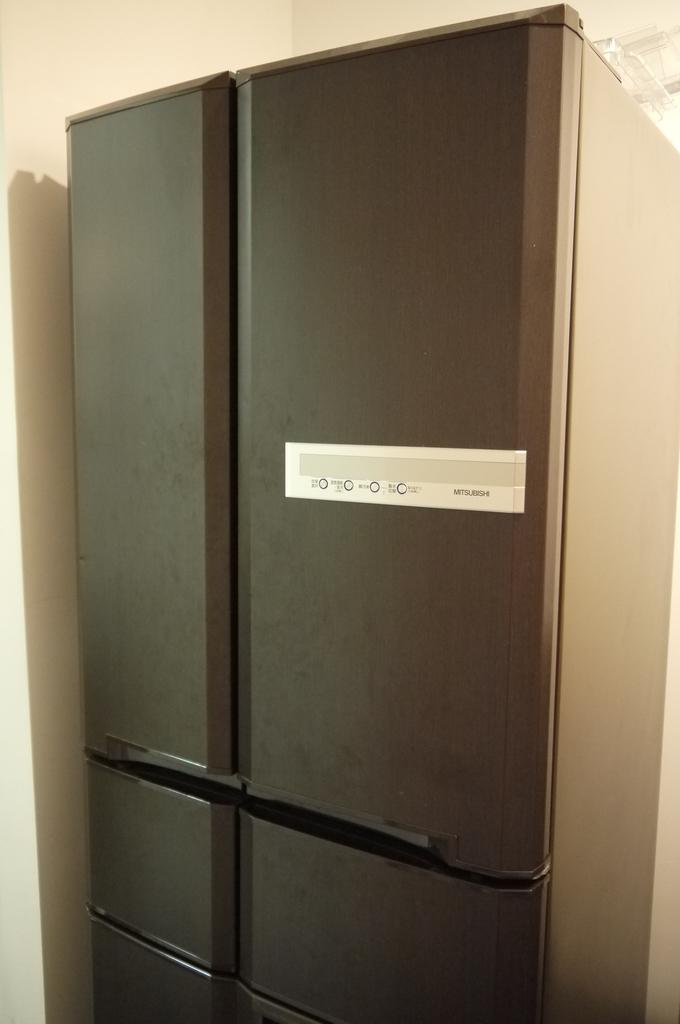How many compartments does this storage device have?
Give a very brief answer. Answering does not require reading text in the image. 